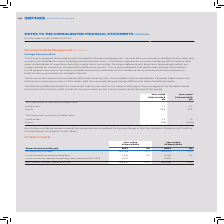According to Sophos Group's financial document, Where does the currency exchange differences that the Group experiences arise from? arising upon retranslation of monetary items (primarily short-term inter-Company balances and long-term borrowings), which are recognised as an expense in the period the difference occurs.. The document states: "he Group experiences currency exchange differences arising upon retranslation of monetary items (primarily short-term inter-Company balances and long-..." Also, How would any foreign exchange variance be recognised? as unrealised foreign exchange in the Consolidated Statement of Profit or Loss and have no impact on cash flows.. The document states: "Any foreign exchange variance would be recognised as unrealised foreign exchange in the Consolidated Statement of Profit or Loss and have no impact on..." Also, For which currencies does the table record the effect of a 10% movement against the US dollar? The document shows two values: Sterling and Euro. From the document: "10% movement in sterling to US dollar value 10% movement in euro to US dollar value..." Additionally, In which year was the impact on Equity from a 10% movement in sterling to US dollar value larger? According to the financial document, 2018. The relevant text states: "Year-ended 31 March 2019 Year-ended 31 March 2018..." Also, can you calculate: What was the change in the impact on Equity from a 10% movement in sterling to US dollar value in 2019 from 2018? Based on the calculation: 33.8-37.4, the result is -3.6 (in millions). This is based on the information: "Equity 33.8 37.4 Equity 33.8 37.4..." The key data points involved are: 33.8, 37.4. Also, can you calculate: What was the percentage change in the impact on Equity from a 10% movement in sterling to US dollar value in 2019 from 2018? To answer this question, I need to perform calculations using the financial data. The calculation is: (33.8-37.4)/37.4, which equals -9.63 (percentage). This is based on the information: "Equity 33.8 37.4 Equity 33.8 37.4..." The key data points involved are: 33.8, 37.4. 